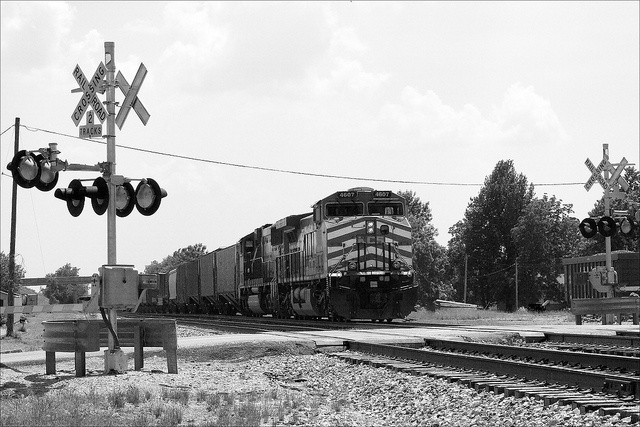Describe the objects in this image and their specific colors. I can see train in gray, black, darkgray, and lightgray tones, traffic light in gray, black, white, and darkgray tones, traffic light in gray, black, darkgray, and white tones, traffic light in gray, black, darkgray, and lightgray tones, and traffic light in gray, black, darkgray, and lightgray tones in this image. 